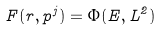<formula> <loc_0><loc_0><loc_500><loc_500>F ( r , p ^ { j } ) = \Phi ( E , L ^ { 2 } )</formula> 